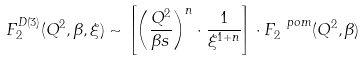Convert formula to latex. <formula><loc_0><loc_0><loc_500><loc_500>F _ { 2 } ^ { D ( 3 ) } ( Q ^ { 2 } , \beta , \xi ) \sim \left [ \left ( \frac { Q ^ { 2 } } { \beta s } \right ) ^ { n } \cdot \frac { 1 } { \xi ^ { 1 + n } } \right ] \cdot F _ { 2 } ^ { \ p o m } ( Q ^ { 2 } , \beta )</formula> 